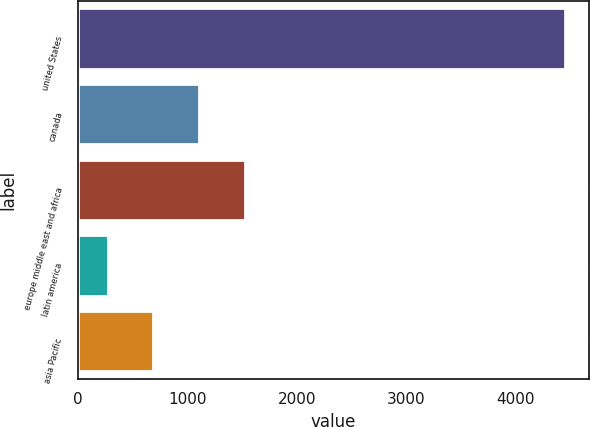<chart> <loc_0><loc_0><loc_500><loc_500><bar_chart><fcel>united States<fcel>canada<fcel>europe middle east and africa<fcel>latin america<fcel>asia Pacific<nl><fcel>4447.2<fcel>1109.76<fcel>1526.94<fcel>275.4<fcel>692.58<nl></chart> 